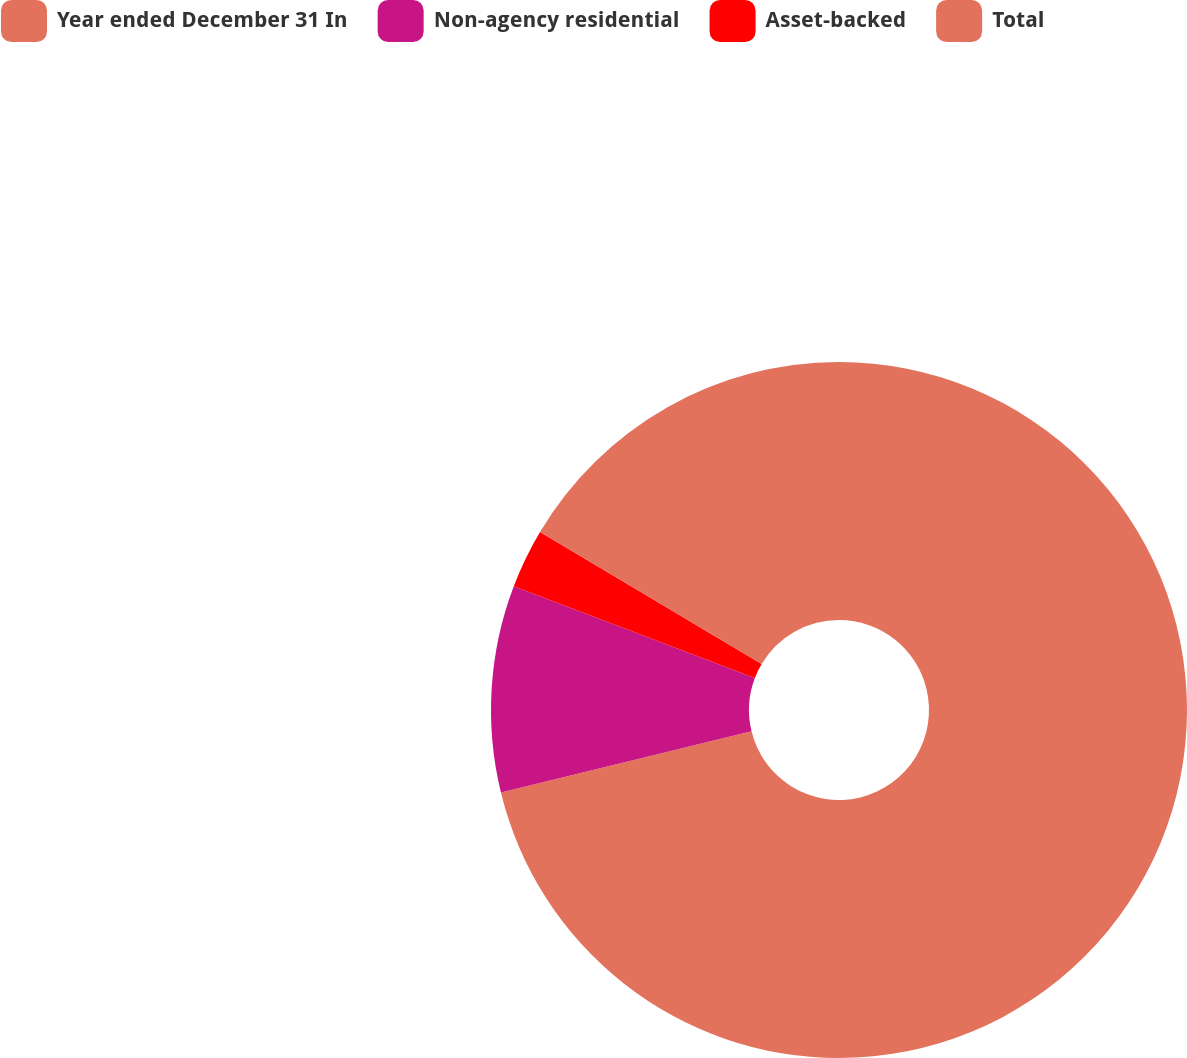<chart> <loc_0><loc_0><loc_500><loc_500><pie_chart><fcel>Year ended December 31 In<fcel>Non-agency residential<fcel>Asset-backed<fcel>Total<nl><fcel>71.19%<fcel>9.6%<fcel>2.76%<fcel>16.45%<nl></chart> 